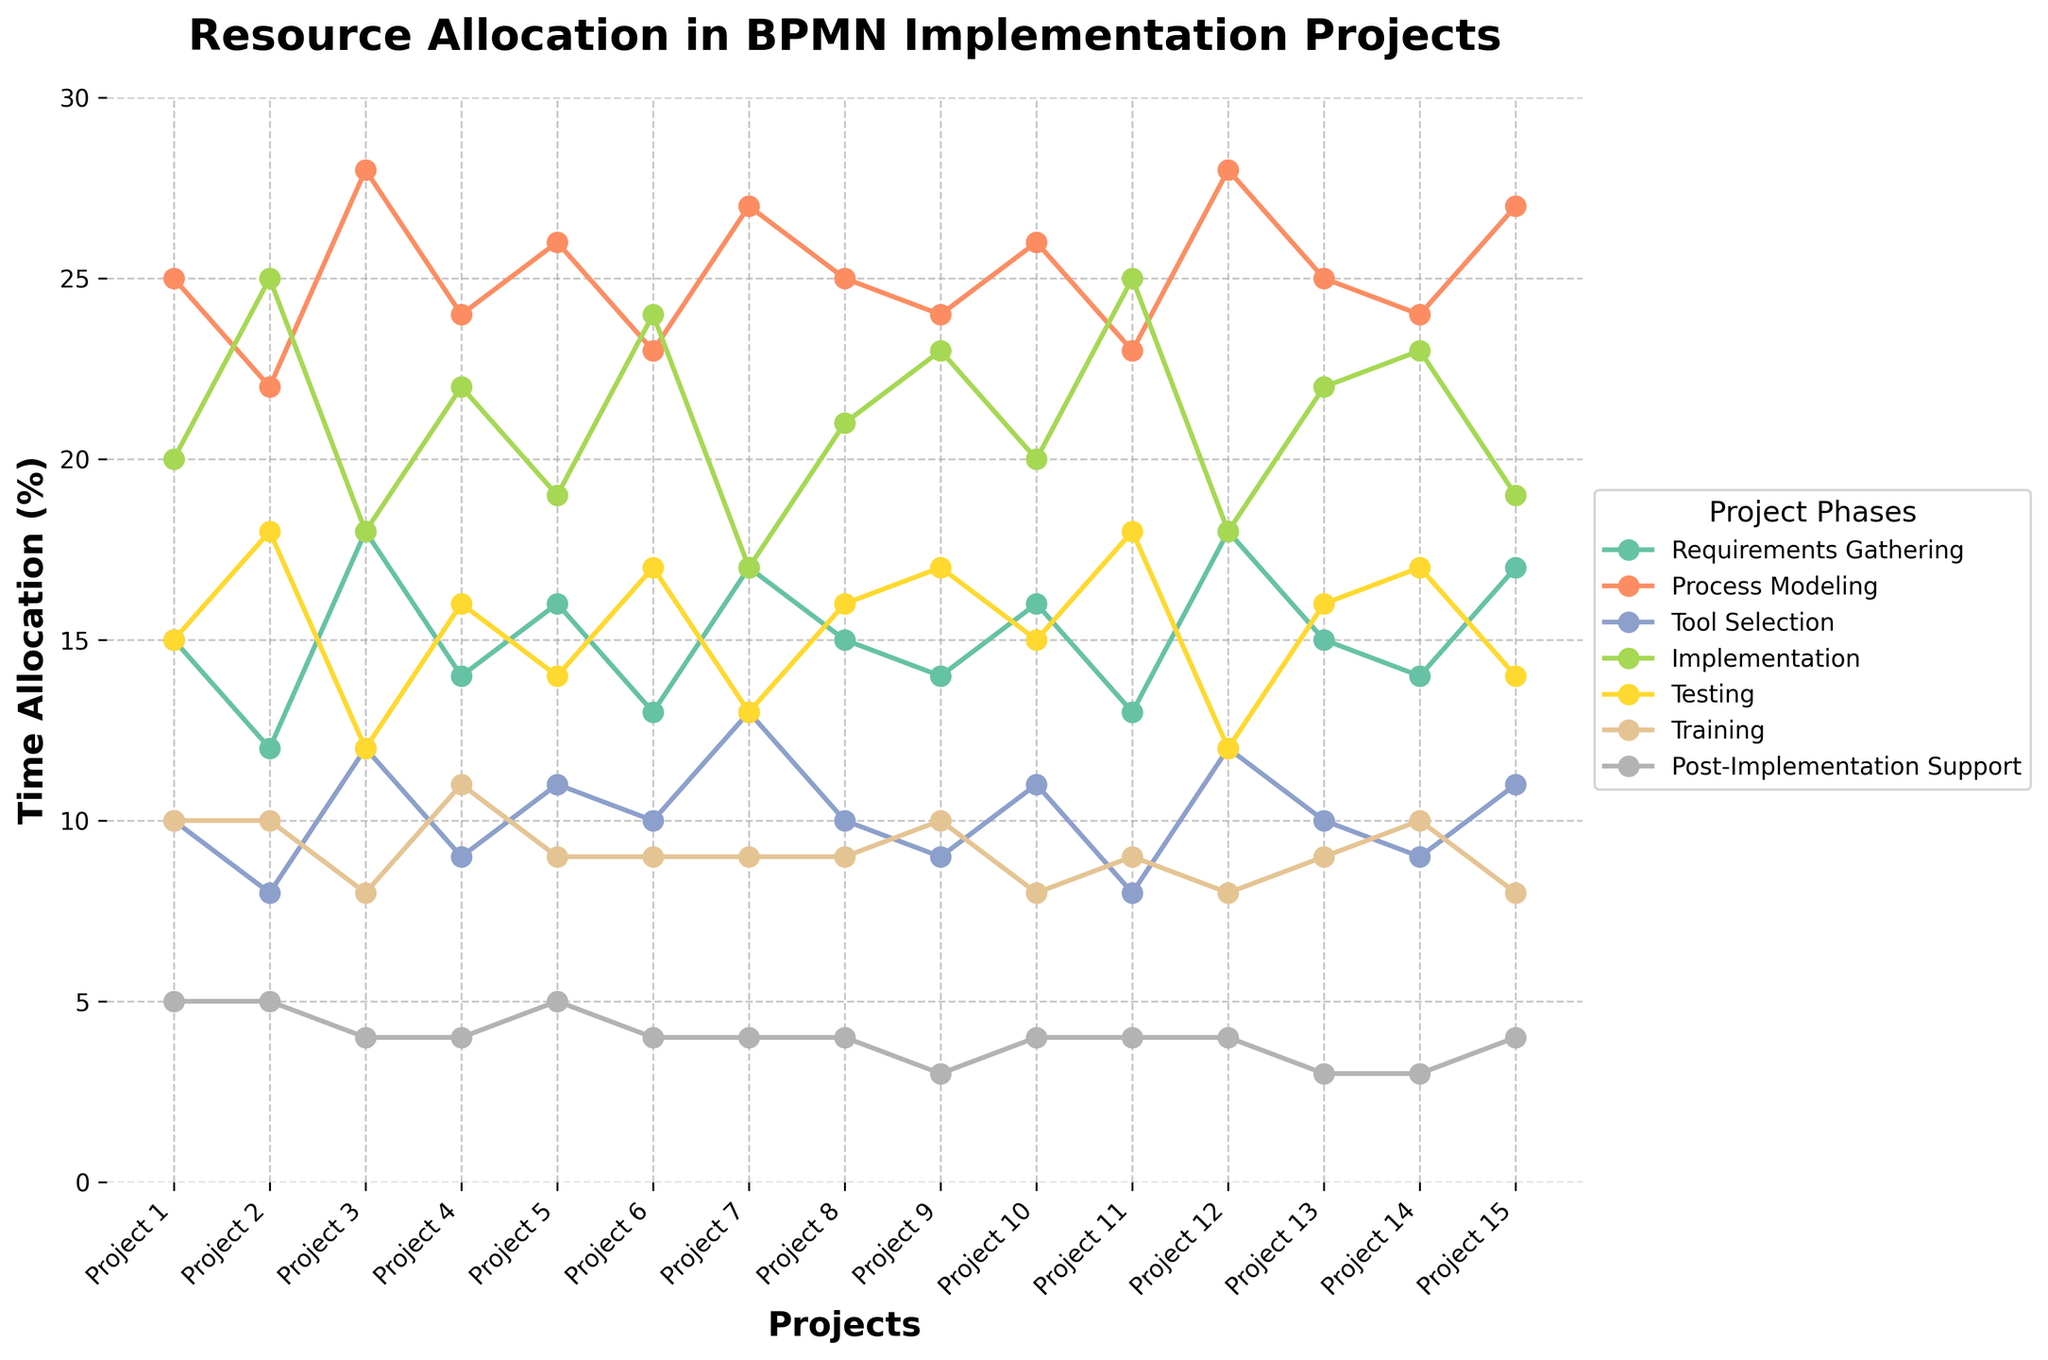Which project allocated the most time to Implementation? Look for the highest point on the Implementation line (typically represented by a specific color). Identify the corresponding project on the x-axis.
Answer: Project 2 and Project 11 (both at 25%) What's the total time spent on Training across all projects? Add the values of the Training phase for all projects. The total sum is 10 + 10 + 8 + 11 + 9 + 9 + 9 + 9 + 10 + 8 + 9 + 8 + 9 + 10 + 8
Answer: 137 Which phases had the widest variation in time allocation across projects? Examine the range of values for each phase line. Phases like Process Modeling and Implementation cover a wider range of values on the y-axis.
Answer: Process Modeling and Implementation Is there any project where the requirements gathering and testing phases have equal time allocation? Compare the values of Requirements Gathering and Testing for each project. None of the projects have equal values for these two phases.
Answer: No How does the time allocation for Post-Implementation Support compare between Project 2 and Project 4? Check the y-values of the Post-Implementation Support line for Project 2 and Project 4. Both projects show the same value of 5 and 4 respectively.
Answer: Project 2: 5, Project 4: 4 Which project spent the least time on the Post-Implementation Support phase? Identify the lowest point on the Post-Implementation Support line (typically represented by a specific color). The lowest value corresponds to the project(s) with the least time allocated.
Answer: Project 9 and Project 13 (both at 3%) What is the average time allocation for Process Modeling across all projects? Add the values for Process Modeling across all projects and divide by the number of projects (15). The sum is 25 + 22 + 28 + 24 + 26 + 23 + 27 + 25 + 24 + 26 + 23 + 28 + 25 + 24 + 27, which totals 377. 377/15 = 25.13
Answer: 25.13 Compare the total time allocated to Requirements Gathering for the first five projects and the last five projects Sum the values of Requirements Gathering for the first five and last five projects (15 + 12 + 18 + 14 + 16) vs (16 + 13 + 18 + 14 + 17). The totals are 75 and 78 respectively
Answer: First five: 75, Last five: 78 